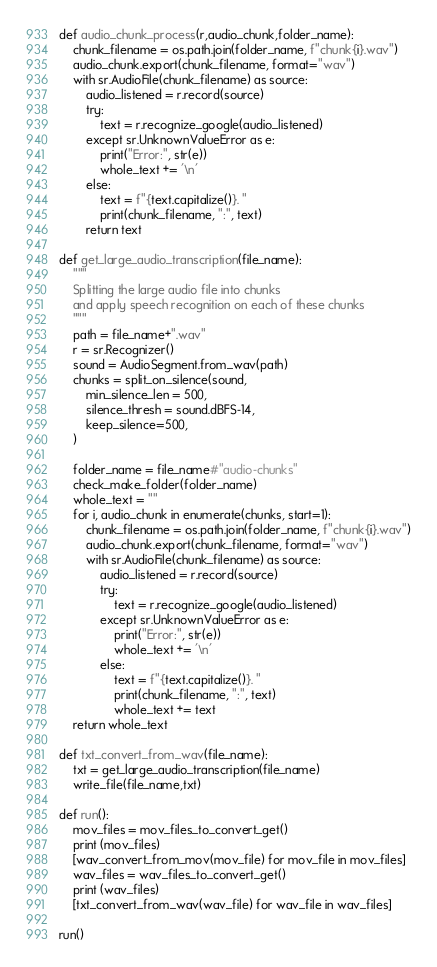<code> <loc_0><loc_0><loc_500><loc_500><_Python_>

def audio_chunk_process(r,audio_chunk,folder_name):
    chunk_filename = os.path.join(folder_name, f"chunk{i}.wav")
    audio_chunk.export(chunk_filename, format="wav")
    with sr.AudioFile(chunk_filename) as source:
        audio_listened = r.record(source)
        try:
            text = r.recognize_google(audio_listened)
        except sr.UnknownValueError as e:
            print("Error:", str(e))
            whole_text += '\n'
        else:
            text = f"{text.capitalize()}. "
            print(chunk_filename, ":", text)
        return text
        
def get_large_audio_transcription(file_name):
    """
    Splitting the large audio file into chunks
    and apply speech recognition on each of these chunks
    """
    path = file_name+".wav"
    r = sr.Recognizer()
    sound = AudioSegment.from_wav(path)  
    chunks = split_on_silence(sound,
        min_silence_len = 500,
        silence_thresh = sound.dBFS-14,
        keep_silence=500,
    )

    folder_name = file_name#"audio-chunks"
    check_make_folder(folder_name)
    whole_text = ""
    for i, audio_chunk in enumerate(chunks, start=1):
        chunk_filename = os.path.join(folder_name, f"chunk{i}.wav")
        audio_chunk.export(chunk_filename, format="wav")
        with sr.AudioFile(chunk_filename) as source:
            audio_listened = r.record(source)
            try:
                text = r.recognize_google(audio_listened)
            except sr.UnknownValueError as e:
                print("Error:", str(e))
                whole_text += '\n'
            else:
                text = f"{text.capitalize()}. "
                print(chunk_filename, ":", text)
                whole_text += text
    return whole_text

def txt_convert_from_wav(file_name):
    txt = get_large_audio_transcription(file_name)
    write_file(file_name,txt)
    
def run():
    mov_files = mov_files_to_convert_get()
    print (mov_files)
    [wav_convert_from_mov(mov_file) for mov_file in mov_files]
    wav_files = wav_files_to_convert_get()
    print (wav_files)
    [txt_convert_from_wav(wav_file) for wav_file in wav_files]
    
run()</code> 